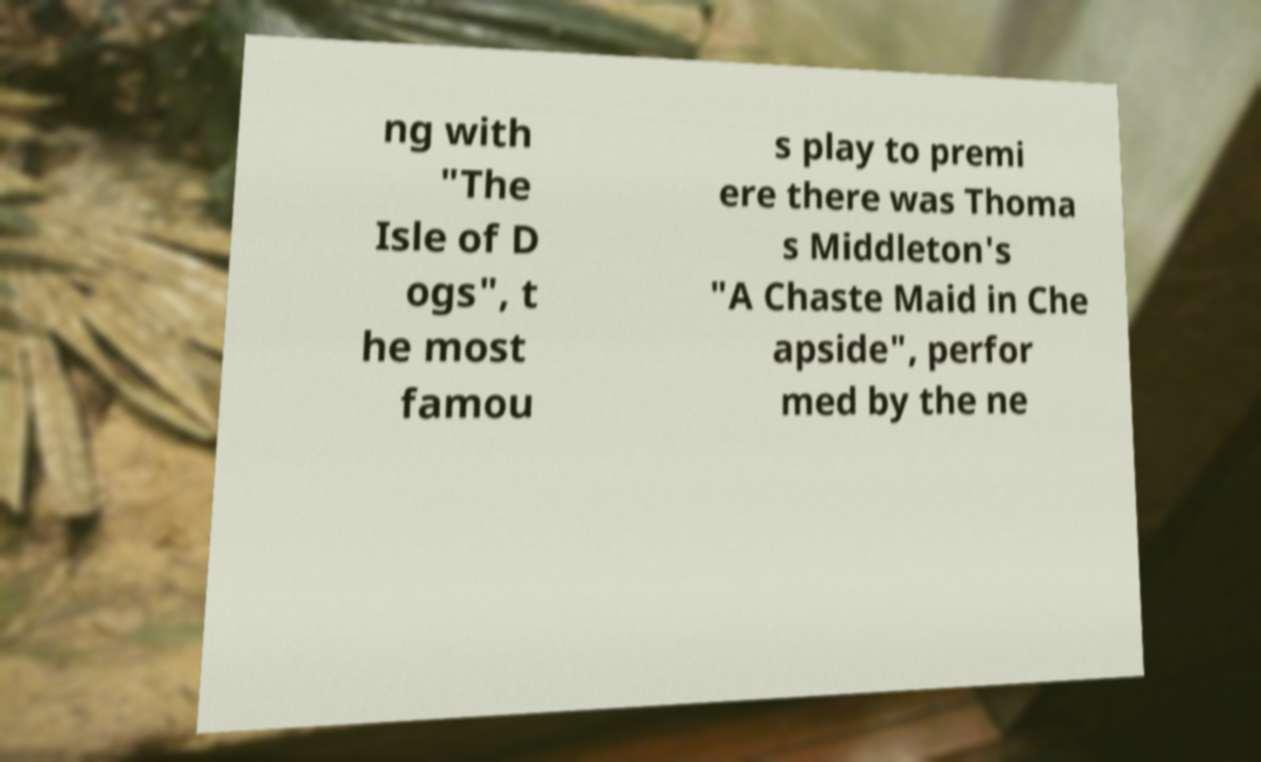Please identify and transcribe the text found in this image. ng with "The Isle of D ogs", t he most famou s play to premi ere there was Thoma s Middleton's "A Chaste Maid in Che apside", perfor med by the ne 